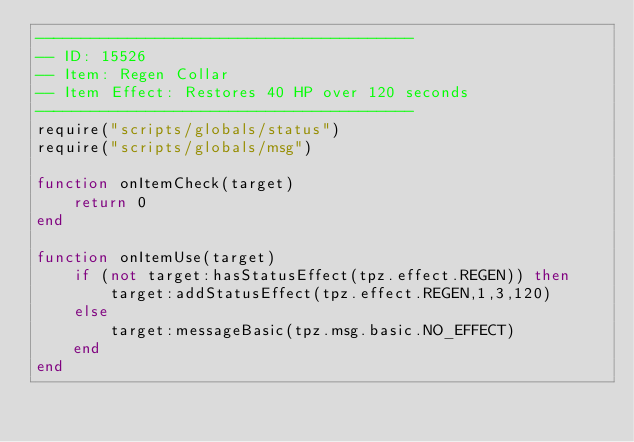Convert code to text. <code><loc_0><loc_0><loc_500><loc_500><_Lua_>-----------------------------------------
-- ID: 15526
-- Item: Regen Collar
-- Item Effect: Restores 40 HP over 120 seconds
-----------------------------------------
require("scripts/globals/status")
require("scripts/globals/msg")

function onItemCheck(target)
    return 0
end

function onItemUse(target)
    if (not target:hasStatusEffect(tpz.effect.REGEN)) then
        target:addStatusEffect(tpz.effect.REGEN,1,3,120)
    else
        target:messageBasic(tpz.msg.basic.NO_EFFECT)
    end
end
</code> 